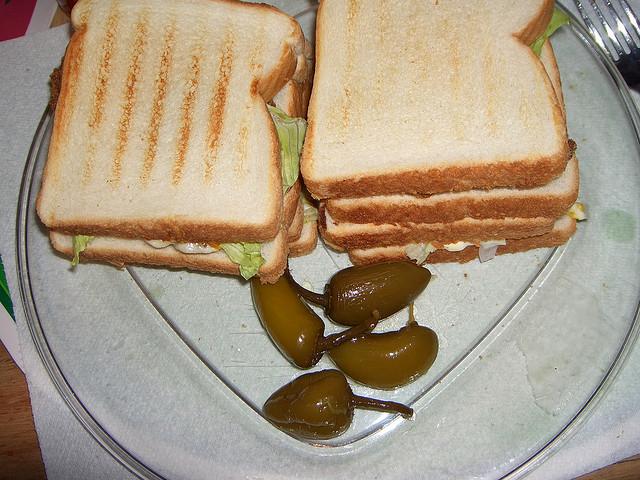What is being made?
Answer briefly. Sandwich. Is one of the toasts a double-decker?
Quick response, please. Yes. Is the bread toasted?
Be succinct. Yes. How many slices of bread are here?
Give a very brief answer. 8. 